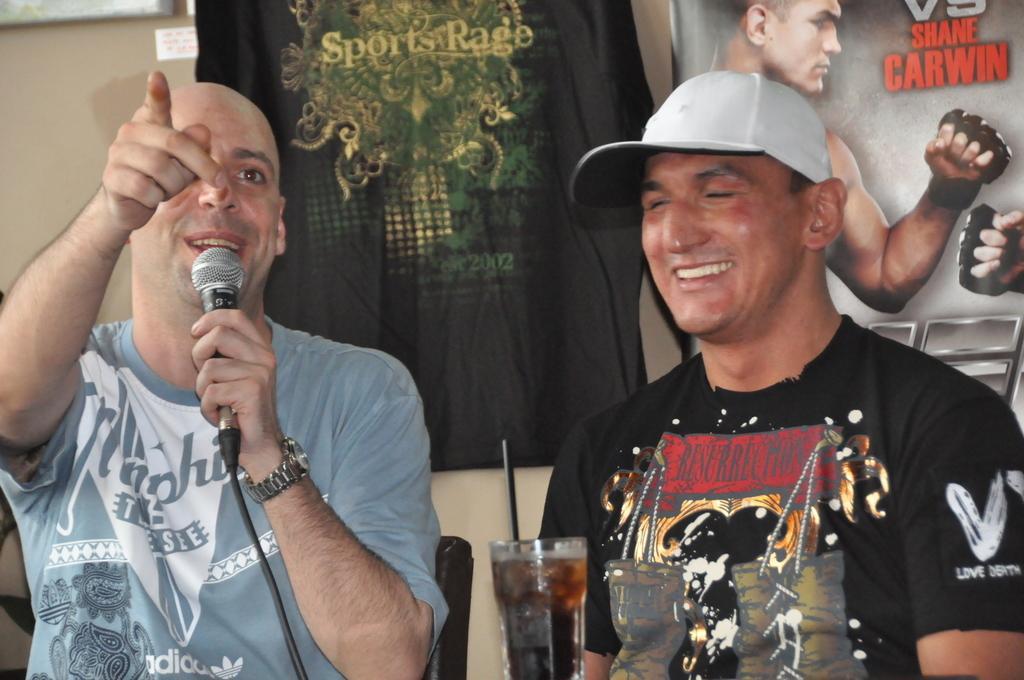Please provide a concise description of this image. In this picture there are two people sitting , to the left side a guy is holding a mic in his hand and black shirt guy is smiling. We also observe a coke glass kept on the tale. In the background we observe a tshirt named as sports rage and beside it there is a poster. 